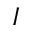Convert formula to latex. <formula><loc_0><loc_0><loc_500><loc_500>I</formula> 